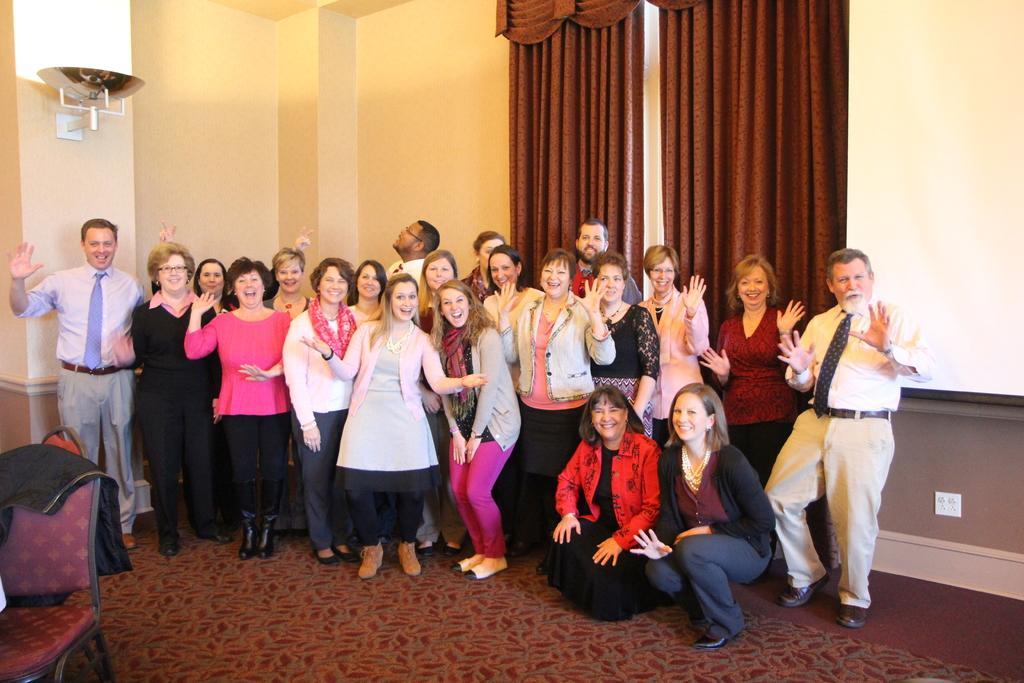Could you give a brief overview of what you see in this image? In this image I can see group of people and these people are wearing the different color dresses. To the left I can see the chair and the cloth on it. In the back there are brown color curtains and the wall. 